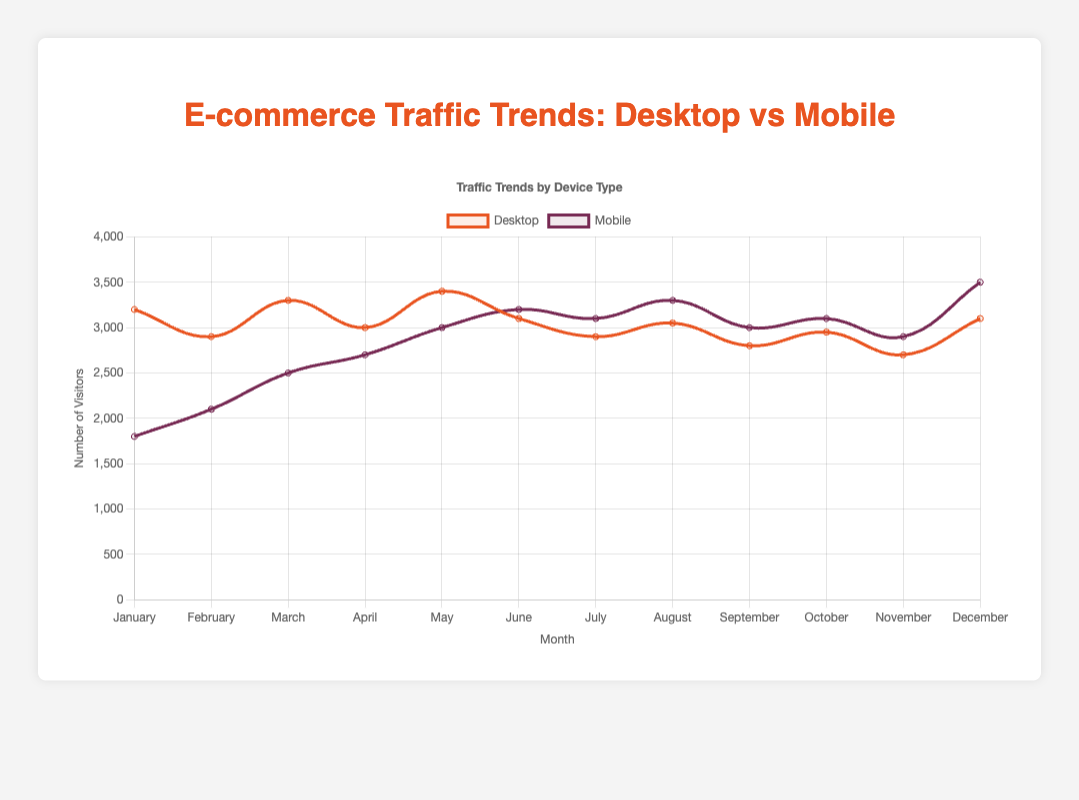Which month had the highest mobile traffic? Look for the month with the tallest purple line representing mobile traffic. December has the highest mobile traffic at 3500 visitors.
Answer: December Which month had the lowest desktop traffic? Look for the shortest orange line representing desktop traffic. November has the lowest desktop traffic at 2700 visitors.
Answer: November What is the average number of desktop visitors from January to June? Sum the desktop visitors from January to June (3200 + 2900 + 3300 + 3000 + 3400 + 3100) and divide by 6. The average is (3200 + 2900 + 3300 + 3000 + 3400 + 3100) / 6 = 3150.
Answer: 3150 How many more mobile visitors were there in December compared to January? Subtract the number of mobile visitors in January from the number in December: 3500 - 1800. There were 1700 more mobile visitors in December compared to January.
Answer: 1700 Which month had a higher number of visitors from desktop than from mobile? Compare the values of desktop and mobile visitors for each month. From the chart, January is an example where desktop visitors (3200) were higher than mobile visitors (1800).
Answer: January What is the total number of visitors (both desktop and mobile) in May? Add the desktop and mobile visitors in May: 3400 (desktop) + 3000 (mobile). The total number of visitors in May is 3400 + 3000 = 6400.
Answer: 6400 In which months did mobile visitors outnumber desktop visitors? Compare the heights of the purple (mobile) and orange (desktop) lines for each month. From the chart, mobile visitors outnumber desktop visitors in June (3200 > 3100), July (3100 > 2900), August (3300 > 3050), October (3100 > 2950), and December (3500 > 3100).
Answer: June, July, August, October, December By how much did desktop traffic increase from February to March? Subtract the number of desktop visitors in February from the number in March: 3300 - 2900. Desktop traffic increased by 400 visitors from February to March.
Answer: 400 What is the total number of mobile visitors from July to December? Sum the mobile visitors from July to December (3100 + 3300 + 3000 + 3100 + 2900 + 3500). The total is 3100 + 3300 + 3000 + 3100 + 2900 + 3500 = 18900.
Answer: 18900 